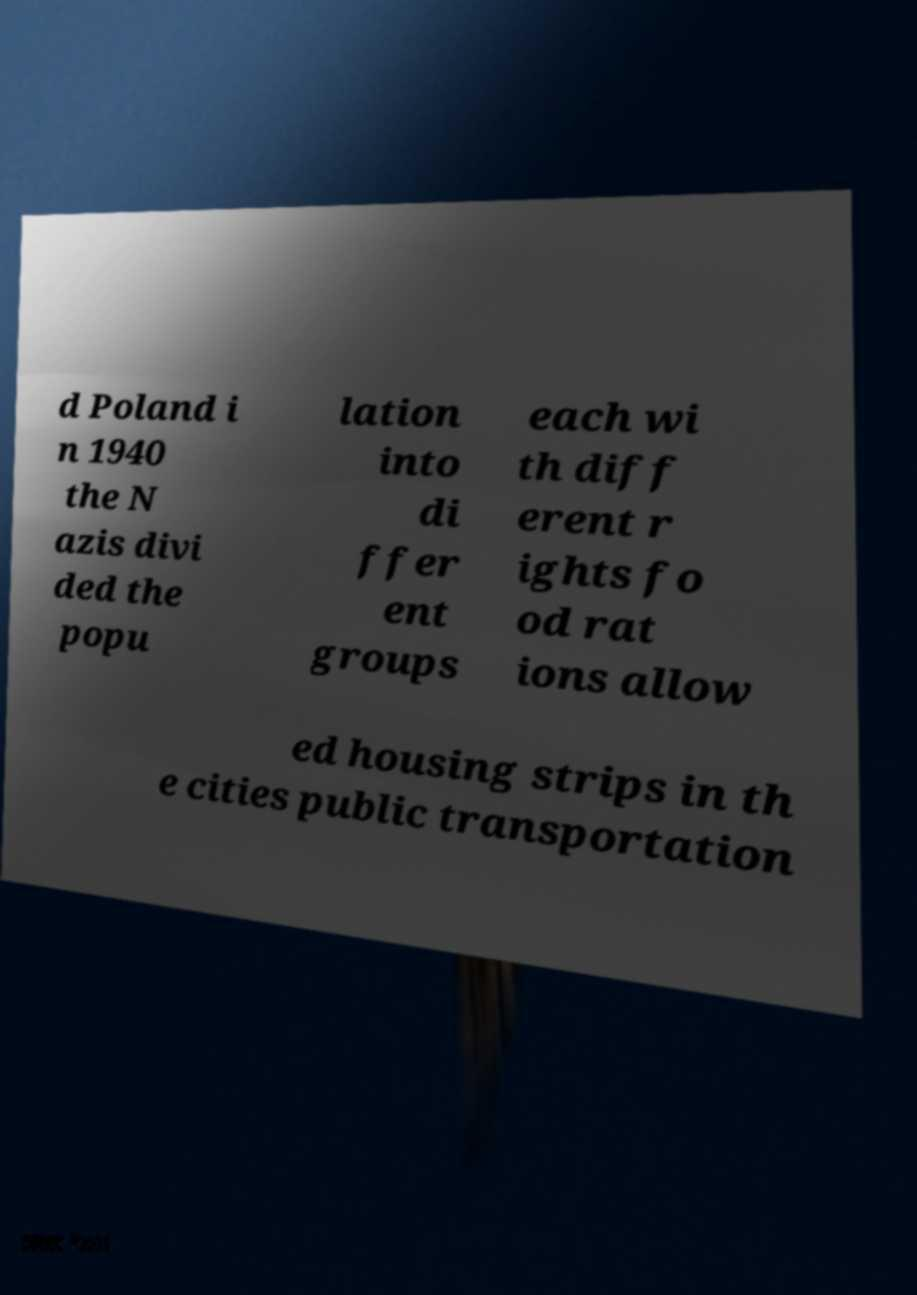Could you extract and type out the text from this image? d Poland i n 1940 the N azis divi ded the popu lation into di ffer ent groups each wi th diff erent r ights fo od rat ions allow ed housing strips in th e cities public transportation 